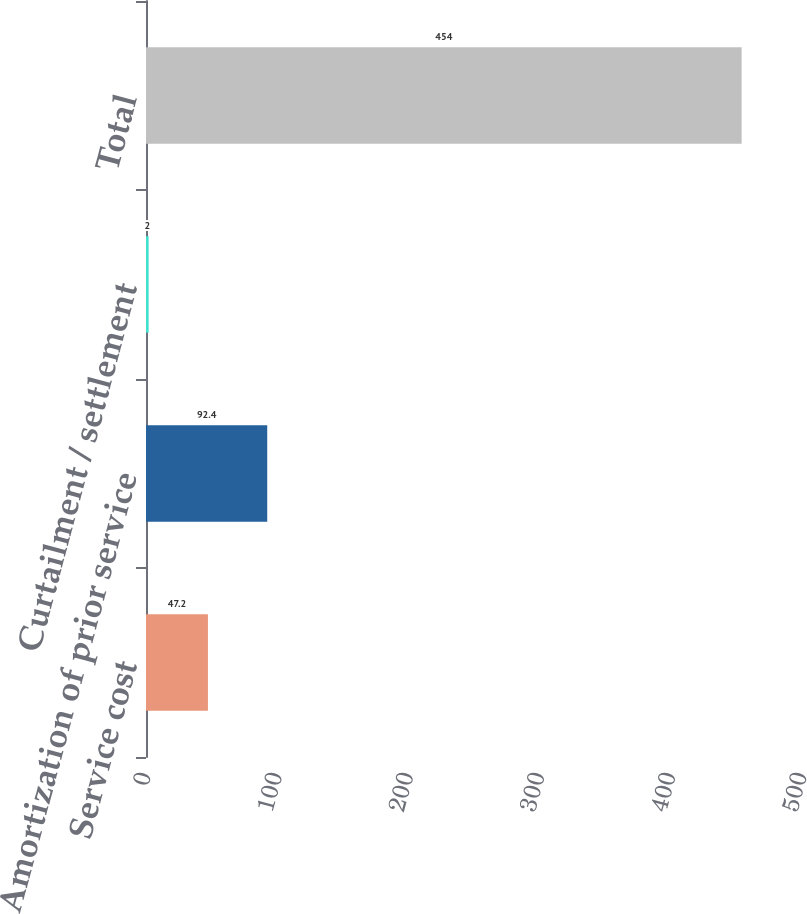Convert chart to OTSL. <chart><loc_0><loc_0><loc_500><loc_500><bar_chart><fcel>Service cost<fcel>Amortization of prior service<fcel>Curtailment / settlement<fcel>Total<nl><fcel>47.2<fcel>92.4<fcel>2<fcel>454<nl></chart> 